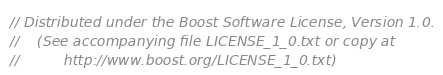Convert code to text. <code><loc_0><loc_0><loc_500><loc_500><_C++_>// Distributed under the Boost Software License, Version 1.0.
//    (See accompanying file LICENSE_1_0.txt or copy at
//          http://www.boost.org/LICENSE_1_0.txt)

</code> 